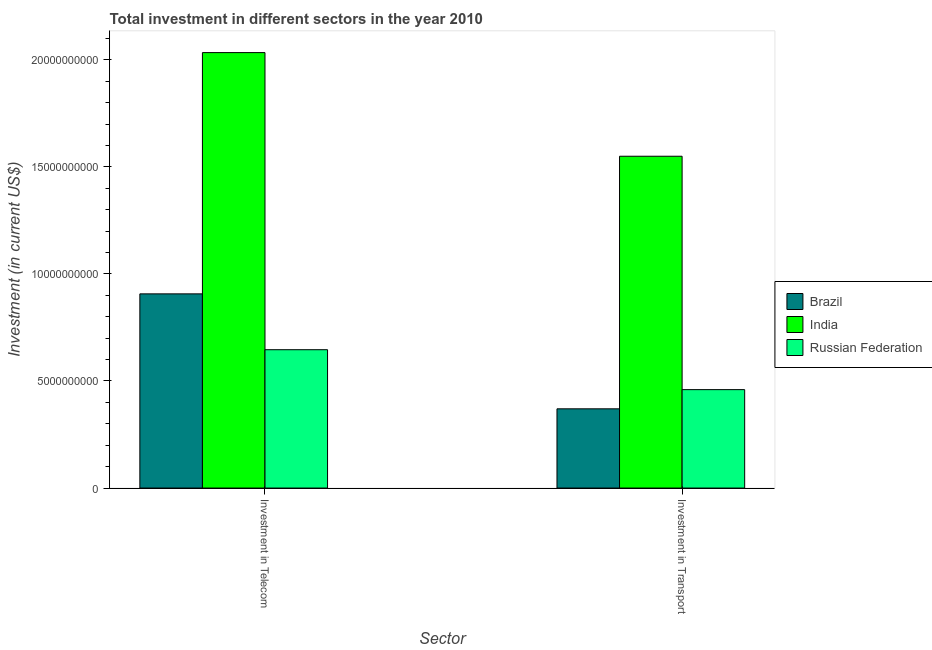Are the number of bars per tick equal to the number of legend labels?
Keep it short and to the point. Yes. Are the number of bars on each tick of the X-axis equal?
Provide a succinct answer. Yes. How many bars are there on the 1st tick from the right?
Provide a succinct answer. 3. What is the label of the 2nd group of bars from the left?
Offer a very short reply. Investment in Transport. What is the investment in transport in India?
Ensure brevity in your answer.  1.55e+1. Across all countries, what is the maximum investment in telecom?
Make the answer very short. 2.03e+1. Across all countries, what is the minimum investment in transport?
Provide a succinct answer. 3.70e+09. In which country was the investment in telecom minimum?
Make the answer very short. Russian Federation. What is the total investment in telecom in the graph?
Provide a short and direct response. 3.59e+1. What is the difference between the investment in transport in Russian Federation and that in Brazil?
Your answer should be very brief. 8.96e+08. What is the difference between the investment in telecom in India and the investment in transport in Brazil?
Offer a very short reply. 1.66e+1. What is the average investment in telecom per country?
Provide a succinct answer. 1.20e+1. What is the difference between the investment in transport and investment in telecom in Brazil?
Keep it short and to the point. -5.37e+09. In how many countries, is the investment in telecom greater than 18000000000 US$?
Provide a short and direct response. 1. What is the ratio of the investment in transport in Brazil to that in India?
Provide a succinct answer. 0.24. In how many countries, is the investment in transport greater than the average investment in transport taken over all countries?
Ensure brevity in your answer.  1. What does the 3rd bar from the left in Investment in Transport represents?
Your response must be concise. Russian Federation. What does the 1st bar from the right in Investment in Telecom represents?
Give a very brief answer. Russian Federation. How many bars are there?
Your response must be concise. 6. Are all the bars in the graph horizontal?
Provide a short and direct response. No. Are the values on the major ticks of Y-axis written in scientific E-notation?
Your answer should be compact. No. Where does the legend appear in the graph?
Provide a succinct answer. Center right. What is the title of the graph?
Ensure brevity in your answer.  Total investment in different sectors in the year 2010. What is the label or title of the X-axis?
Ensure brevity in your answer.  Sector. What is the label or title of the Y-axis?
Give a very brief answer. Investment (in current US$). What is the Investment (in current US$) in Brazil in Investment in Telecom?
Your answer should be compact. 9.07e+09. What is the Investment (in current US$) of India in Investment in Telecom?
Your response must be concise. 2.03e+1. What is the Investment (in current US$) in Russian Federation in Investment in Telecom?
Give a very brief answer. 6.46e+09. What is the Investment (in current US$) in Brazil in Investment in Transport?
Provide a succinct answer. 3.70e+09. What is the Investment (in current US$) of India in Investment in Transport?
Give a very brief answer. 1.55e+1. What is the Investment (in current US$) in Russian Federation in Investment in Transport?
Ensure brevity in your answer.  4.60e+09. Across all Sector, what is the maximum Investment (in current US$) in Brazil?
Offer a terse response. 9.07e+09. Across all Sector, what is the maximum Investment (in current US$) in India?
Offer a terse response. 2.03e+1. Across all Sector, what is the maximum Investment (in current US$) of Russian Federation?
Provide a succinct answer. 6.46e+09. Across all Sector, what is the minimum Investment (in current US$) of Brazil?
Provide a succinct answer. 3.70e+09. Across all Sector, what is the minimum Investment (in current US$) in India?
Your response must be concise. 1.55e+1. Across all Sector, what is the minimum Investment (in current US$) in Russian Federation?
Your answer should be very brief. 4.60e+09. What is the total Investment (in current US$) in Brazil in the graph?
Your response must be concise. 1.28e+1. What is the total Investment (in current US$) in India in the graph?
Your response must be concise. 3.58e+1. What is the total Investment (in current US$) in Russian Federation in the graph?
Give a very brief answer. 1.11e+1. What is the difference between the Investment (in current US$) in Brazil in Investment in Telecom and that in Investment in Transport?
Your answer should be compact. 5.37e+09. What is the difference between the Investment (in current US$) of India in Investment in Telecom and that in Investment in Transport?
Your answer should be very brief. 4.84e+09. What is the difference between the Investment (in current US$) in Russian Federation in Investment in Telecom and that in Investment in Transport?
Make the answer very short. 1.86e+09. What is the difference between the Investment (in current US$) in Brazil in Investment in Telecom and the Investment (in current US$) in India in Investment in Transport?
Offer a terse response. -6.43e+09. What is the difference between the Investment (in current US$) in Brazil in Investment in Telecom and the Investment (in current US$) in Russian Federation in Investment in Transport?
Your answer should be compact. 4.47e+09. What is the difference between the Investment (in current US$) of India in Investment in Telecom and the Investment (in current US$) of Russian Federation in Investment in Transport?
Ensure brevity in your answer.  1.57e+1. What is the average Investment (in current US$) of Brazil per Sector?
Offer a terse response. 6.38e+09. What is the average Investment (in current US$) in India per Sector?
Offer a very short reply. 1.79e+1. What is the average Investment (in current US$) of Russian Federation per Sector?
Your response must be concise. 5.53e+09. What is the difference between the Investment (in current US$) in Brazil and Investment (in current US$) in India in Investment in Telecom?
Offer a terse response. -1.13e+1. What is the difference between the Investment (in current US$) in Brazil and Investment (in current US$) in Russian Federation in Investment in Telecom?
Provide a succinct answer. 2.61e+09. What is the difference between the Investment (in current US$) of India and Investment (in current US$) of Russian Federation in Investment in Telecom?
Your answer should be compact. 1.39e+1. What is the difference between the Investment (in current US$) in Brazil and Investment (in current US$) in India in Investment in Transport?
Your response must be concise. -1.18e+1. What is the difference between the Investment (in current US$) in Brazil and Investment (in current US$) in Russian Federation in Investment in Transport?
Ensure brevity in your answer.  -8.96e+08. What is the difference between the Investment (in current US$) of India and Investment (in current US$) of Russian Federation in Investment in Transport?
Give a very brief answer. 1.09e+1. What is the ratio of the Investment (in current US$) of Brazil in Investment in Telecom to that in Investment in Transport?
Offer a very short reply. 2.45. What is the ratio of the Investment (in current US$) in India in Investment in Telecom to that in Investment in Transport?
Provide a succinct answer. 1.31. What is the ratio of the Investment (in current US$) in Russian Federation in Investment in Telecom to that in Investment in Transport?
Keep it short and to the point. 1.41. What is the difference between the highest and the second highest Investment (in current US$) in Brazil?
Your answer should be compact. 5.37e+09. What is the difference between the highest and the second highest Investment (in current US$) of India?
Your response must be concise. 4.84e+09. What is the difference between the highest and the second highest Investment (in current US$) of Russian Federation?
Your answer should be compact. 1.86e+09. What is the difference between the highest and the lowest Investment (in current US$) in Brazil?
Your answer should be very brief. 5.37e+09. What is the difference between the highest and the lowest Investment (in current US$) in India?
Your answer should be very brief. 4.84e+09. What is the difference between the highest and the lowest Investment (in current US$) in Russian Federation?
Provide a short and direct response. 1.86e+09. 